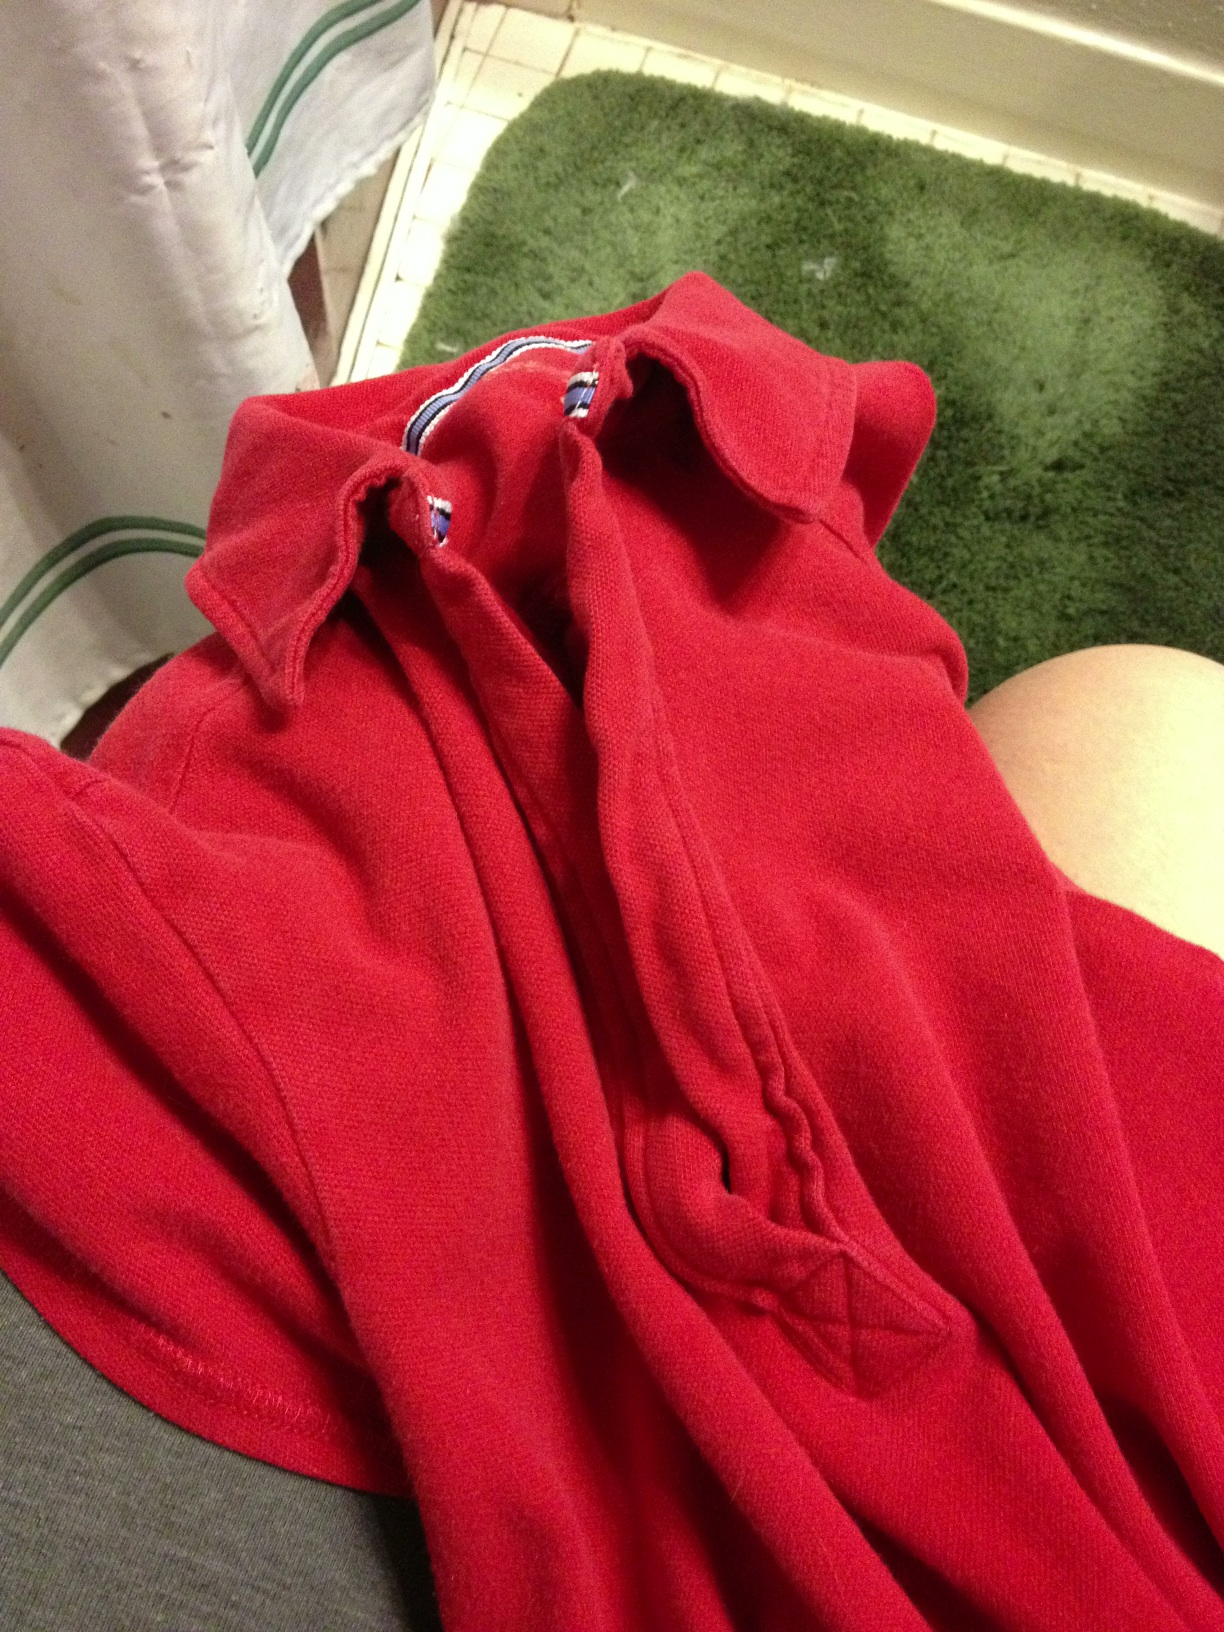What material does the shirt look like it's made from? It appears to be a cotton blend, which often provides both comfort and durability. 